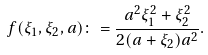<formula> <loc_0><loc_0><loc_500><loc_500>f ( \xi _ { 1 } , \xi _ { 2 } , a ) \colon = \frac { a ^ { 2 } \xi _ { 1 } ^ { 2 } + \xi _ { 2 } ^ { 2 } } { 2 ( a + \xi _ { 2 } ) a ^ { 2 } } .</formula> 